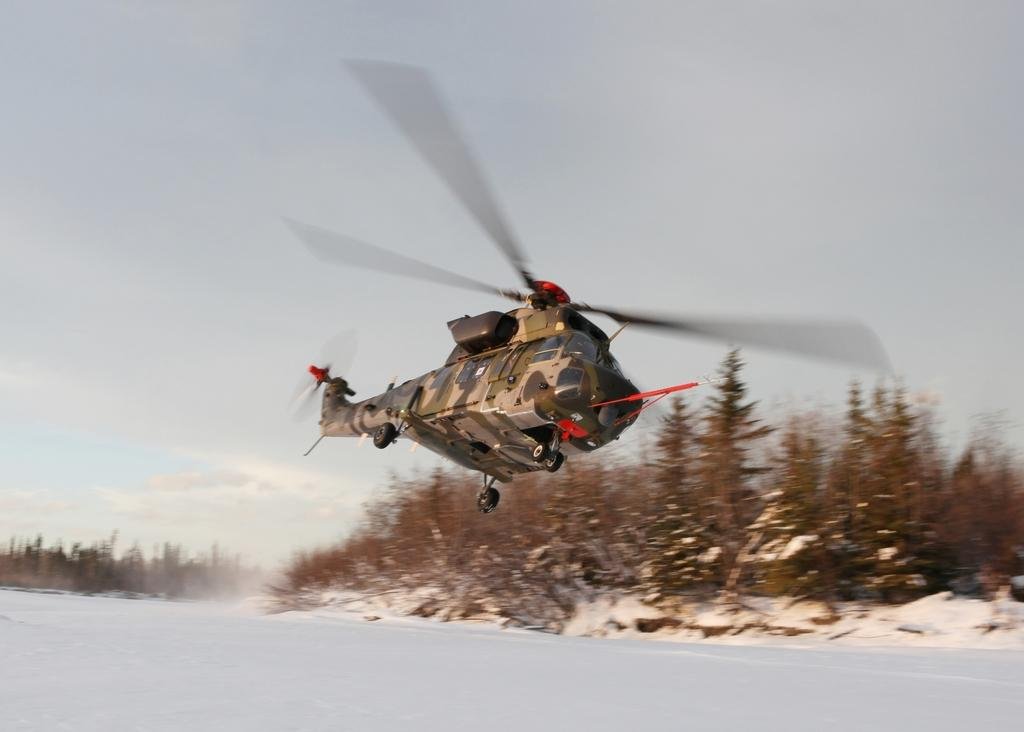What is there is a plane flying in the image, where is it located? The plane is flying in the air in the image. What can be seen in the background of the image? There are trees in the background of the image. What card is the father holding in the image? There is no card or father present in the image; it only features a plane flying in the air and trees in the background. 